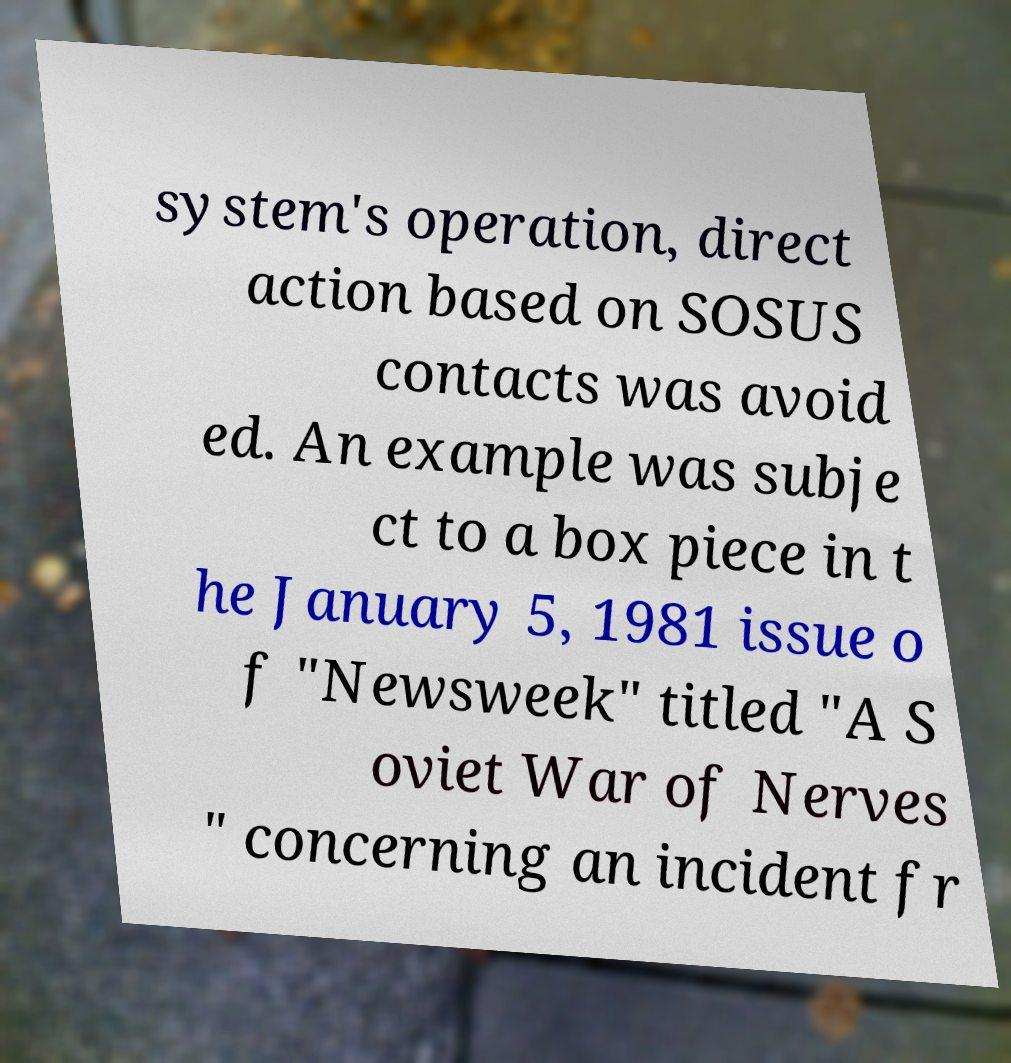For documentation purposes, I need the text within this image transcribed. Could you provide that? system's operation, direct action based on SOSUS contacts was avoid ed. An example was subje ct to a box piece in t he January 5, 1981 issue o f "Newsweek" titled "A S oviet War of Nerves " concerning an incident fr 